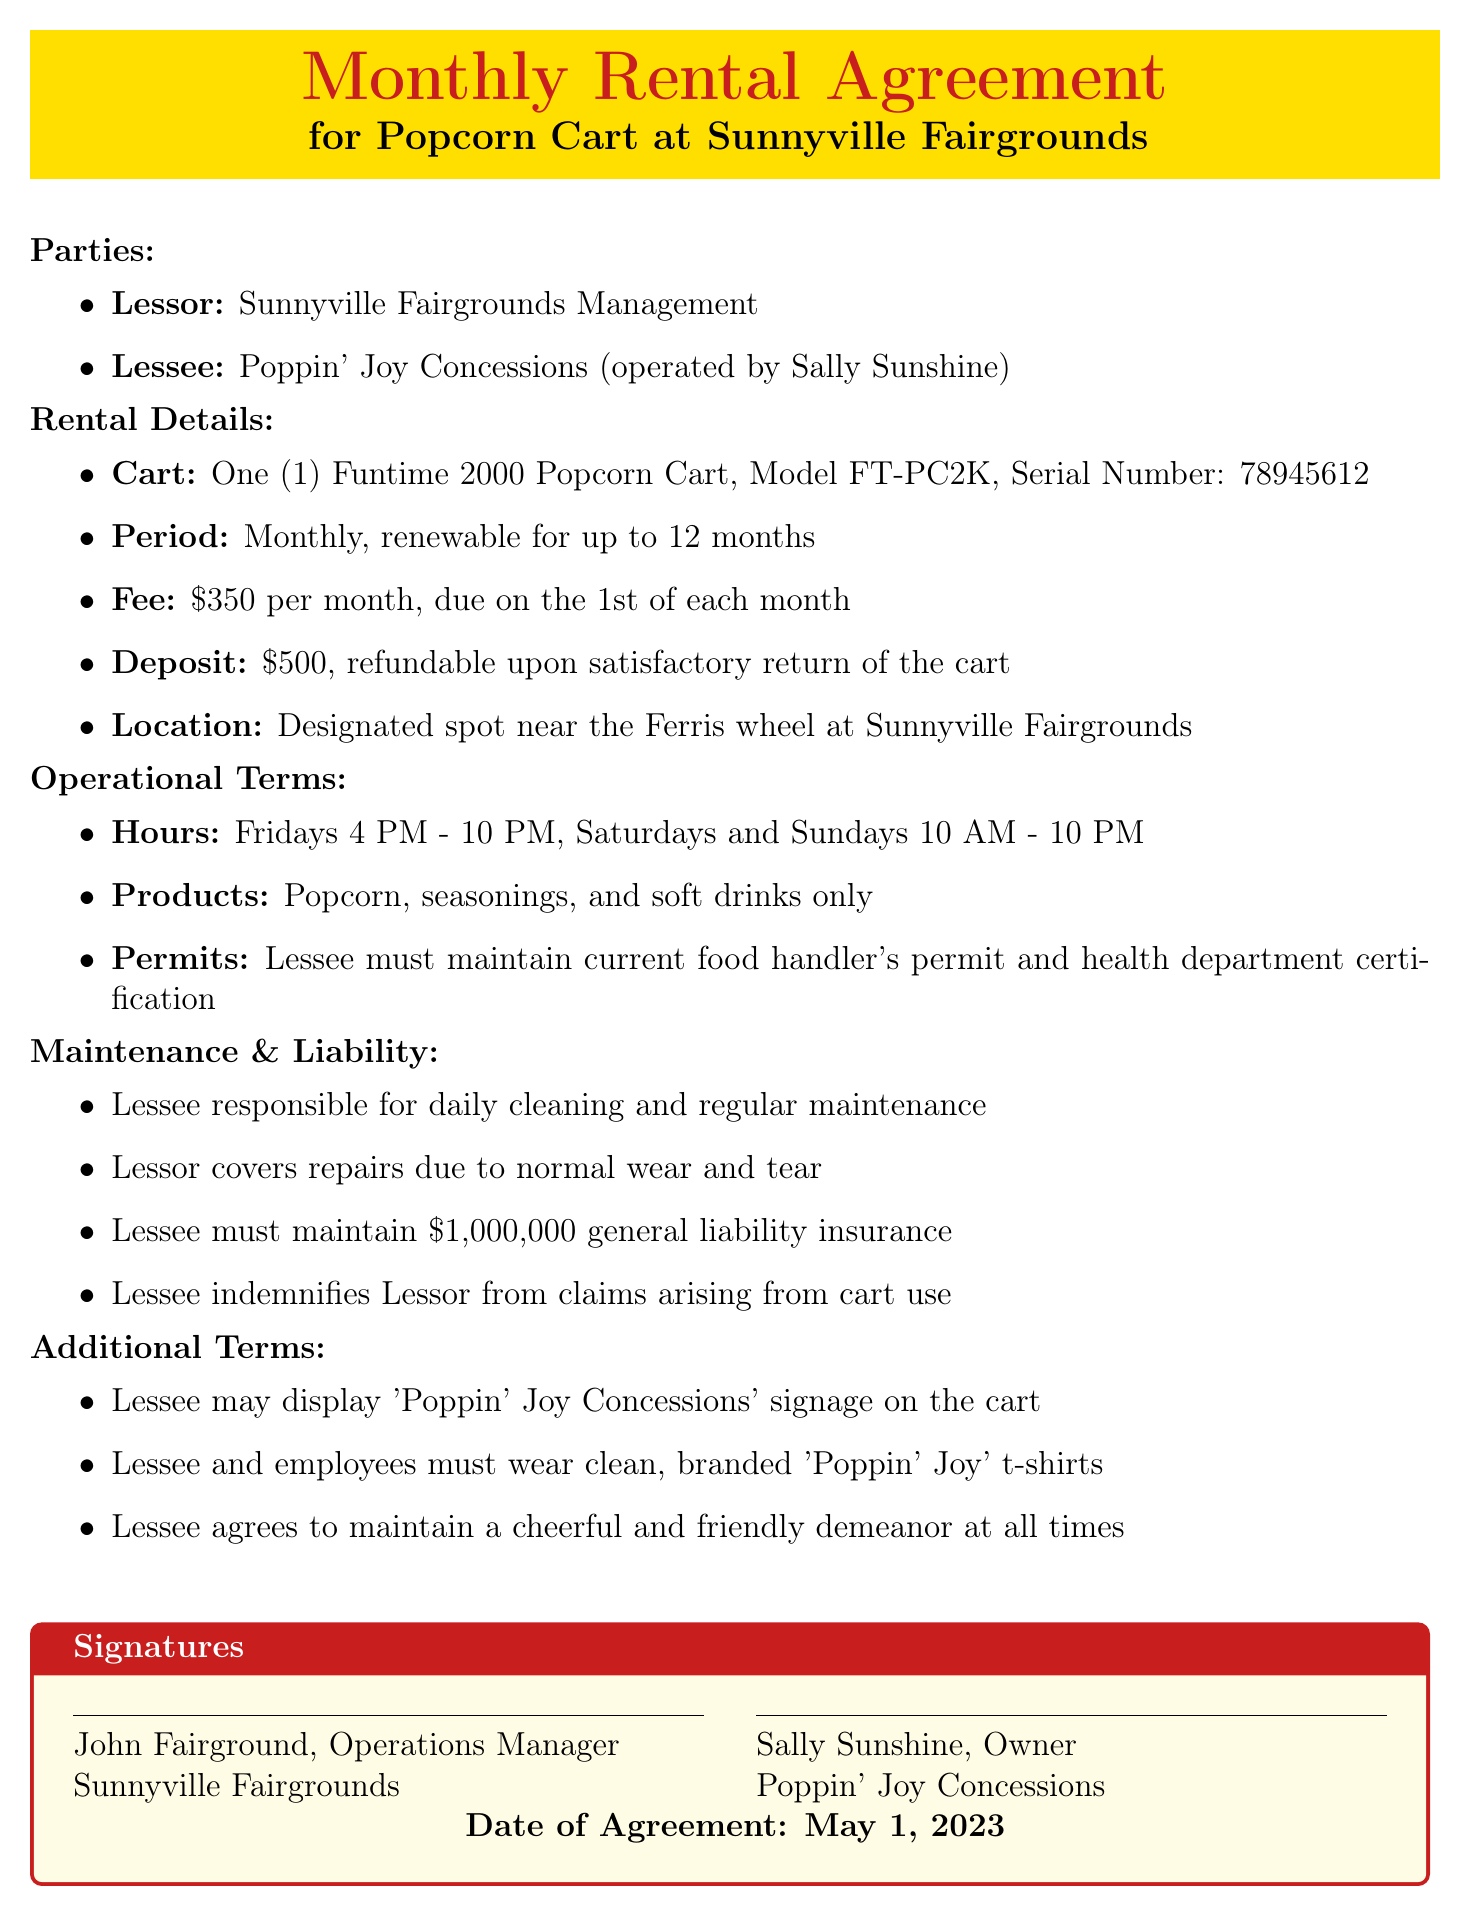What is the rental fee? The rental fee is specified in the document as an amount due each month.
Answer: $350 per month Who is the lessee? The lessee is the party renting the popcorn cart, mentioned under "Parties."
Answer: Poppin' Joy Concessions (operated by Sally Sunshine) What is the security deposit amount? The document specifies the amount required as a security deposit before renting the cart.
Answer: $500 When does the rental agreement start? The date when the agreement was signed is mentioned at the end of the document.
Answer: May 1, 2023 What must the lessee maintain for food safety? The term involving food safety is mentioned under "Operational Terms."
Answer: Current food handler's permit and health department certification How often can the rental agreement be renewed? The renewal terms are included in the document regarding the duration of the rental agreement.
Answer: Up to 12 months What are the hours of operation for the cart? The specific hours mentioned under "Operational Terms" detail when the cart can operate.
Answer: Fridays 4 PM - 10 PM, Saturdays and Sundays 10 AM - 10 PM What is one of the responsibilities of the lessee regarding the cart? The document describes various responsibilities the lessee has in maintaining the cart's condition.
Answer: Daily cleaning of the cart What kind of insurance must the lessee maintain? The insurance requirement is detailed in the liability clauses of the agreement.
Answer: General liability insurance of at least $1,000,000 